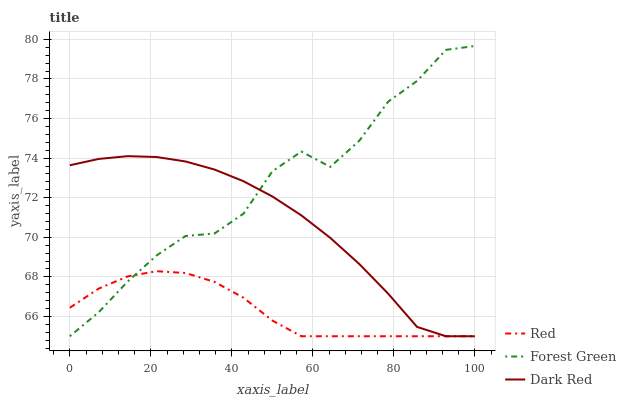Does Red have the minimum area under the curve?
Answer yes or no. Yes. Does Forest Green have the maximum area under the curve?
Answer yes or no. Yes. Does Forest Green have the minimum area under the curve?
Answer yes or no. No. Does Red have the maximum area under the curve?
Answer yes or no. No. Is Red the smoothest?
Answer yes or no. Yes. Is Forest Green the roughest?
Answer yes or no. Yes. Is Forest Green the smoothest?
Answer yes or no. No. Is Red the roughest?
Answer yes or no. No. Does Dark Red have the lowest value?
Answer yes or no. Yes. Does Forest Green have the highest value?
Answer yes or no. Yes. Does Red have the highest value?
Answer yes or no. No. Does Red intersect Forest Green?
Answer yes or no. Yes. Is Red less than Forest Green?
Answer yes or no. No. Is Red greater than Forest Green?
Answer yes or no. No. 